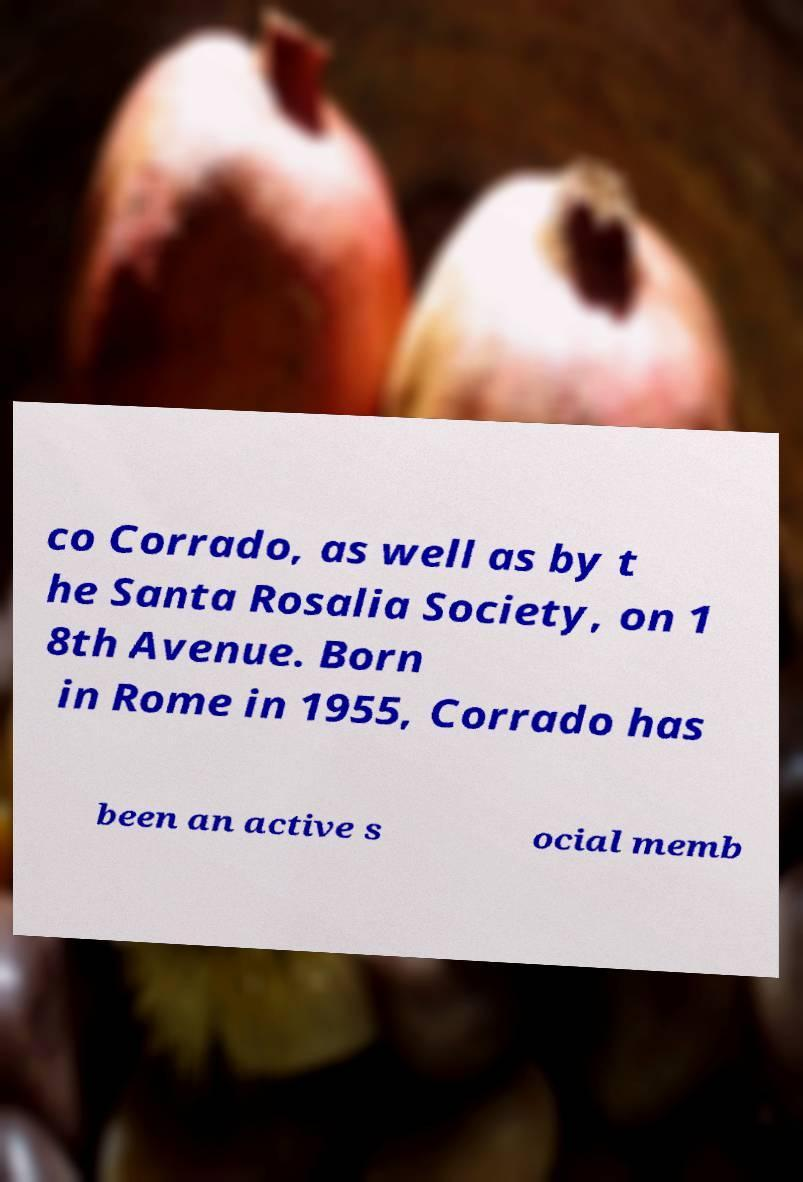Can you accurately transcribe the text from the provided image for me? co Corrado, as well as by t he Santa Rosalia Society, on 1 8th Avenue. Born in Rome in 1955, Corrado has been an active s ocial memb 